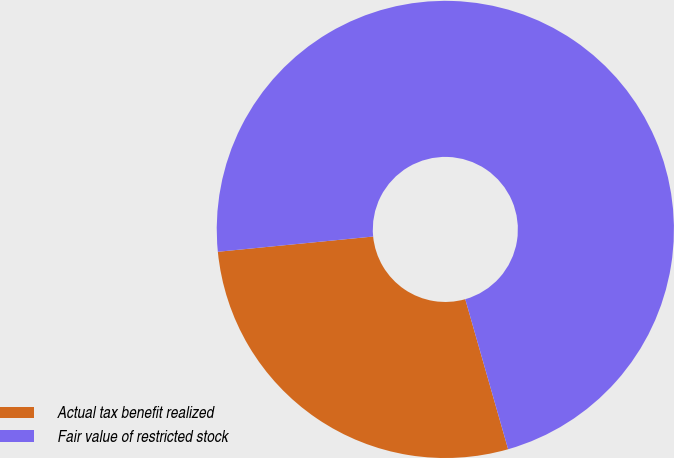<chart> <loc_0><loc_0><loc_500><loc_500><pie_chart><fcel>Actual tax benefit realized<fcel>Fair value of restricted stock<nl><fcel>27.87%<fcel>72.13%<nl></chart> 